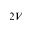<formula> <loc_0><loc_0><loc_500><loc_500>2 V</formula> 